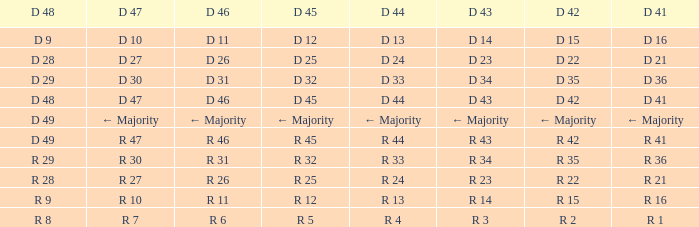Write the full table. {'header': ['D 48', 'D 47', 'D 46', 'D 45', 'D 44', 'D 43', 'D 42', 'D 41'], 'rows': [['D 9', 'D 10', 'D 11', 'D 12', 'D 13', 'D 14', 'D 15', 'D 16'], ['D 28', 'D 27', 'D 26', 'D 25', 'D 24', 'D 23', 'D 22', 'D 21'], ['D 29', 'D 30', 'D 31', 'D 32', 'D 33', 'D 34', 'D 35', 'D 36'], ['D 48', 'D 47', 'D 46', 'D 45', 'D 44', 'D 43', 'D 42', 'D 41'], ['D 49', '← Majority', '← Majority', '← Majority', '← Majority', '← Majority', '← Majority', '← Majority'], ['D 49', 'R 47', 'R 46', 'R 45', 'R 44', 'R 43', 'R 42', 'R 41'], ['R 29', 'R 30', 'R 31', 'R 32', 'R 33', 'R 34', 'R 35', 'R 36'], ['R 28', 'R 27', 'R 26', 'R 25', 'R 24', 'R 23', 'R 22', 'R 21'], ['R 9', 'R 10', 'R 11', 'R 12', 'R 13', 'R 14', 'R 15', 'R 16'], ['R 8', 'R 7', 'R 6', 'R 5', 'R 4', 'R 3', 'R 2', 'R 1']]} Name the D 44 when it has a D 46 of d 31 D 33. 